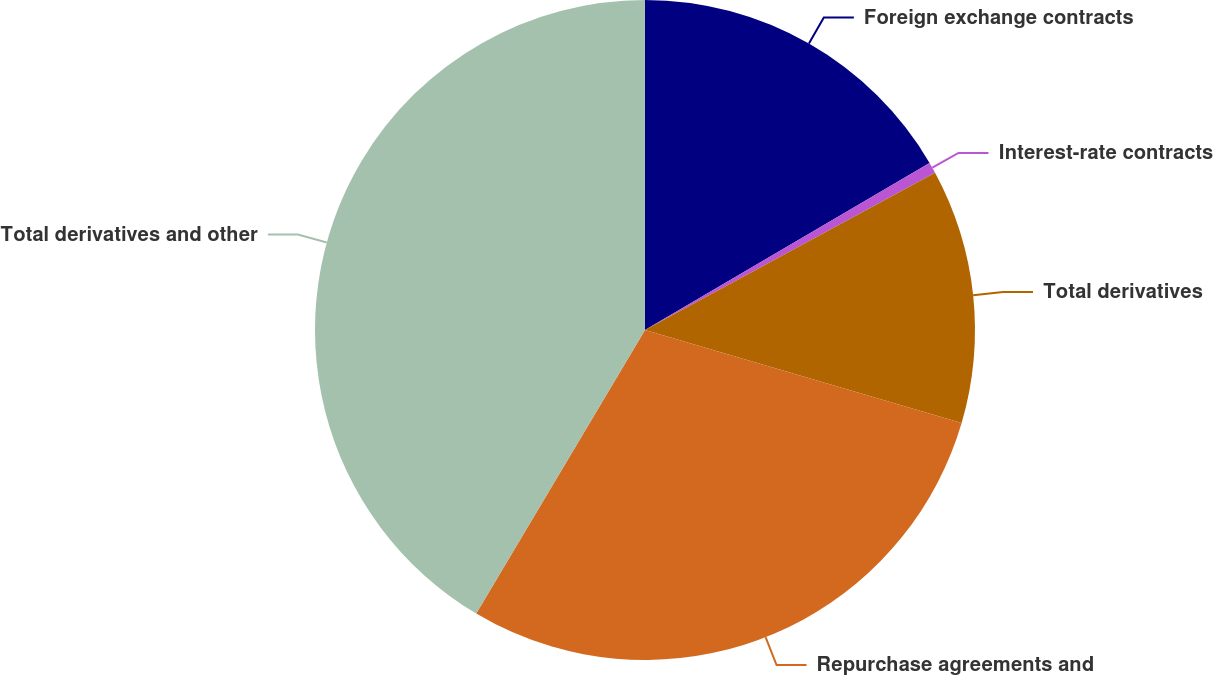<chart> <loc_0><loc_0><loc_500><loc_500><pie_chart><fcel>Foreign exchange contracts<fcel>Interest-rate contracts<fcel>Total derivatives<fcel>Repurchase agreements and<fcel>Total derivatives and other<nl><fcel>16.55%<fcel>0.54%<fcel>12.46%<fcel>29.0%<fcel>41.46%<nl></chart> 